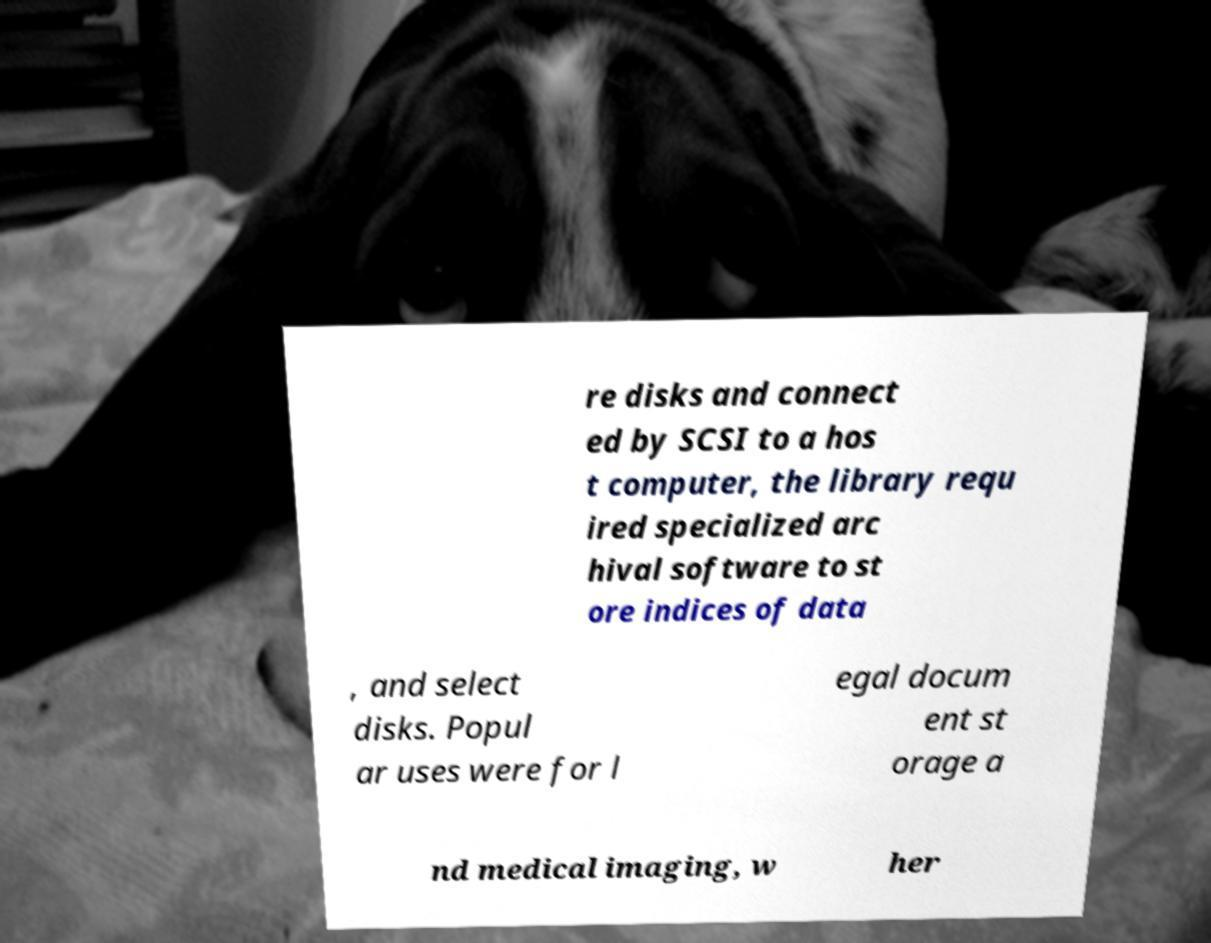What messages or text are displayed in this image? I need them in a readable, typed format. re disks and connect ed by SCSI to a hos t computer, the library requ ired specialized arc hival software to st ore indices of data , and select disks. Popul ar uses were for l egal docum ent st orage a nd medical imaging, w her 